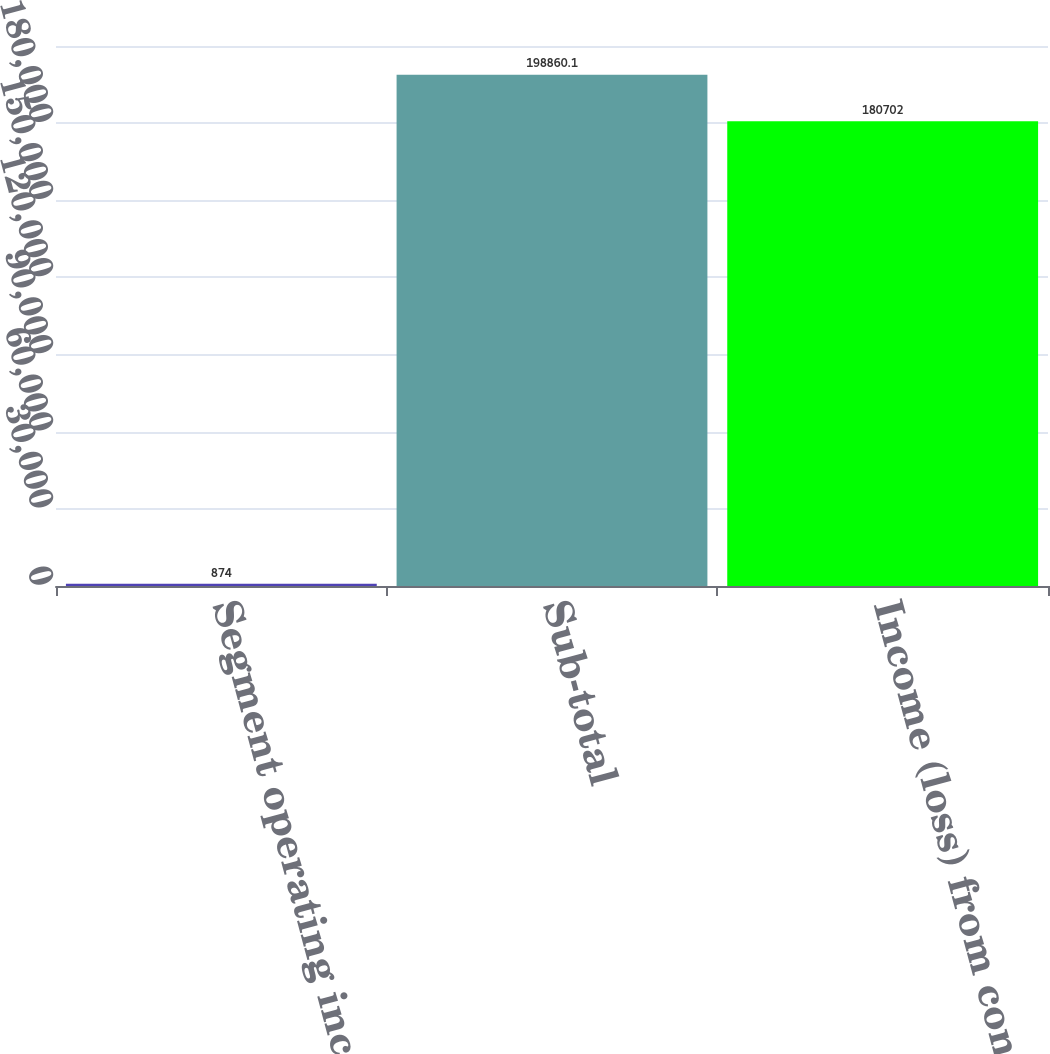Convert chart. <chart><loc_0><loc_0><loc_500><loc_500><bar_chart><fcel>Segment operating income<fcel>Sub-total<fcel>Income (loss) from continuing<nl><fcel>874<fcel>198860<fcel>180702<nl></chart> 